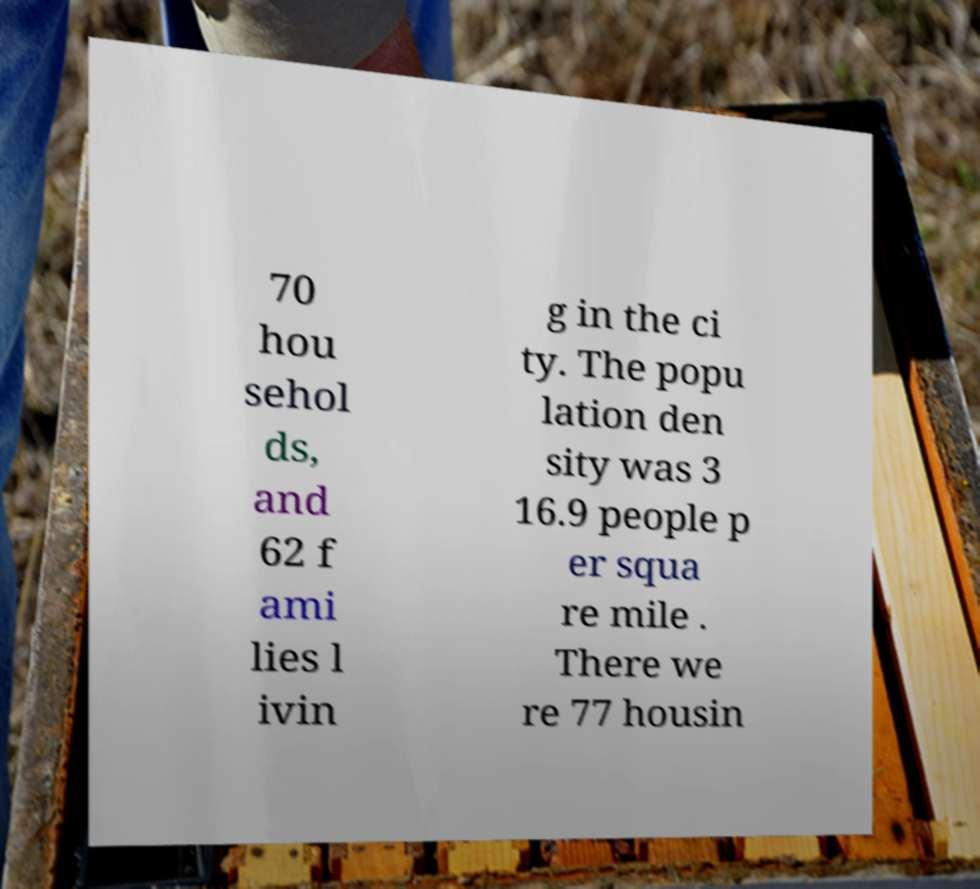Can you accurately transcribe the text from the provided image for me? 70 hou sehol ds, and 62 f ami lies l ivin g in the ci ty. The popu lation den sity was 3 16.9 people p er squa re mile . There we re 77 housin 